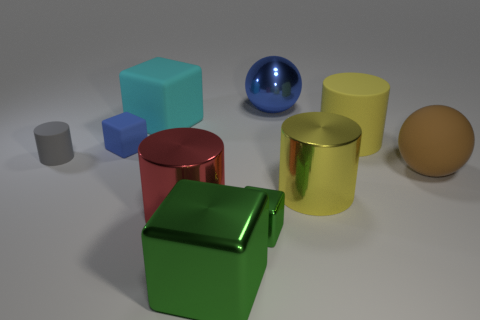Is the color of the shiny ball the same as the tiny cube that is behind the red thing?
Offer a terse response. Yes. Does the big metal cylinder that is on the right side of the blue metal ball have the same color as the big rubber cylinder?
Offer a very short reply. Yes. Is the number of big green metal things that are on the left side of the gray cylinder less than the number of big green blocks in front of the large red shiny cylinder?
Make the answer very short. Yes. The cube that is the same color as the large metal sphere is what size?
Offer a very short reply. Small. Does the large metal ball have the same color as the small rubber cube?
Provide a short and direct response. Yes. There is a rubber sphere that is the same size as the yellow matte object; what color is it?
Make the answer very short. Brown. The tiny matte object that is the same color as the metallic ball is what shape?
Keep it short and to the point. Cube. There is another yellow object that is the same size as the yellow shiny thing; what shape is it?
Give a very brief answer. Cylinder. What is the color of the small rubber thing that is the same shape as the big cyan matte thing?
Your answer should be compact. Blue. Is the number of tiny gray things that are in front of the gray rubber thing the same as the number of tiny matte blocks that are behind the brown matte object?
Provide a succinct answer. No. 